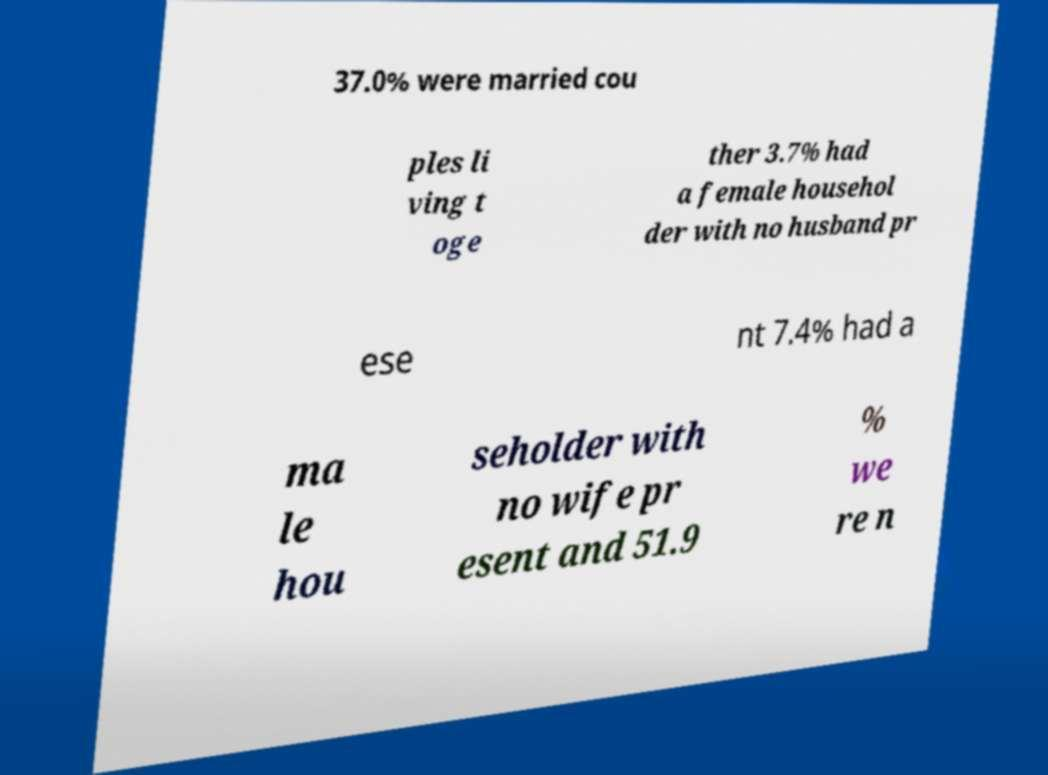There's text embedded in this image that I need extracted. Can you transcribe it verbatim? 37.0% were married cou ples li ving t oge ther 3.7% had a female househol der with no husband pr ese nt 7.4% had a ma le hou seholder with no wife pr esent and 51.9 % we re n 